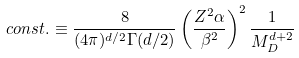Convert formula to latex. <formula><loc_0><loc_0><loc_500><loc_500>c o n s t . \equiv \frac { 8 } { ( 4 \pi ) ^ { d / 2 } \Gamma ( d / 2 ) } \left ( { \frac { Z ^ { 2 } \alpha } { \beta ^ { 2 } } } \right ) ^ { 2 } \frac { 1 } { M _ { D } ^ { d + 2 } }</formula> 